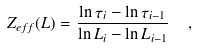<formula> <loc_0><loc_0><loc_500><loc_500>Z _ { e f f } ( L ) = \frac { \ln \tau _ { i } - \ln \tau _ { i - 1 } } { \ln L _ { i } - \ln L _ { i - 1 } } \ \ ,</formula> 